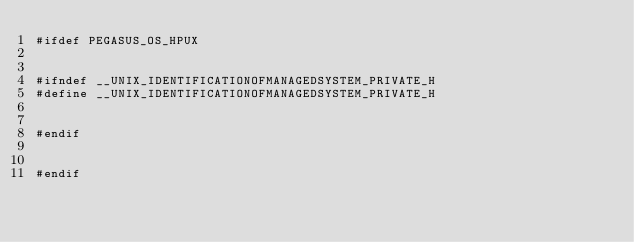<code> <loc_0><loc_0><loc_500><loc_500><_C++_>#ifdef PEGASUS_OS_HPUX


#ifndef __UNIX_IDENTIFICATIONOFMANAGEDSYSTEM_PRIVATE_H
#define __UNIX_IDENTIFICATIONOFMANAGEDSYSTEM_PRIVATE_H


#endif


#endif
</code> 